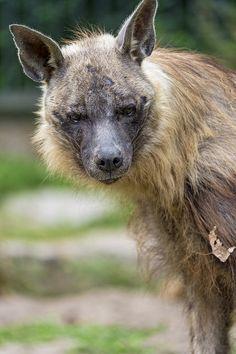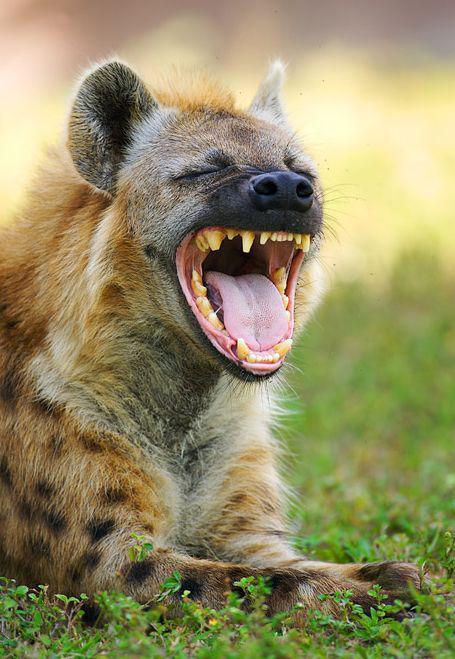The first image is the image on the left, the second image is the image on the right. Considering the images on both sides, is "The images contain a total of one open-mouthed hyena baring fangs." valid? Answer yes or no. Yes. 